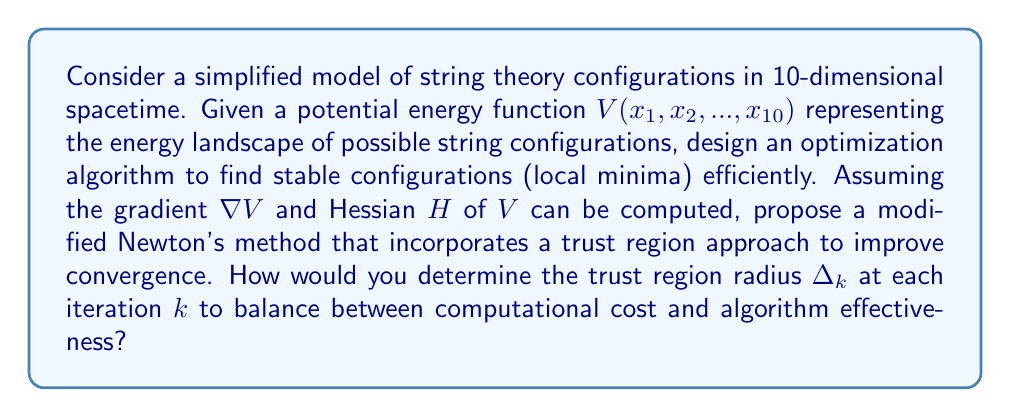Give your solution to this math problem. To solve this problem, we'll design a modified Newton's method with a trust region approach. This method is particularly suitable for finding local minima in high-dimensional spaces, such as the 10-dimensional configuration space in our simplified string theory model.

1. Standard Newton's method:
   The standard Newton's method for optimization is given by:
   $$x_{k+1} = x_k - H_k^{-1}\nabla V_k$$
   where $H_k$ is the Hessian and $\nabla V_k$ is the gradient at $x_k$.

2. Trust Region Modification:
   In the trust region approach, we solve the subproblem:
   $$\min_{p} m_k(p) = V_k + \nabla V_k^T p + \frac{1}{2}p^T H_k p$$
   subject to $\|p\| \leq \Delta_k$, where $\Delta_k$ is the trust region radius.

3. Determining $\Delta_k$:
   We can use the following approach to determine $\Delta_k$:
   
   a. Define the ratio:
      $$\rho_k = \frac{V_k - V(x_k + p_k)}{m_k(0) - m_k(p_k)}$$
   
   b. Update $\Delta_k$ based on $\rho_k$:
      $$\Delta_{k+1} = \begin{cases}
      \alpha_1 \Delta_k & \text{if } \rho_k < \eta_1 \\
      \Delta_k & \text{if } \eta_1 \leq \rho_k < \eta_2 \\
      \alpha_2 \Delta_k & \text{if } \rho_k \geq \eta_2
      \end{cases}$$
      where $0 < \eta_1 < \eta_2 < 1$ and $0 < \alpha_1 < 1 < \alpha_2$.

4. Algorithm steps:
   a. Initialize $x_0$, $\Delta_0$, and parameters $\eta_1$, $\eta_2$, $\alpha_1$, $\alpha_2$.
   b. For each iteration $k$:
      - Compute $\nabla V_k$ and $H_k$.
      - Solve the trust region subproblem to find $p_k$.
      - Compute $\rho_k$.
      - Update $x_{k+1}$ and $\Delta_{k+1}$ based on $\rho_k$.
      - Check for convergence.

5. Balancing computational cost and effectiveness:
   - Smaller $\Delta_k$ leads to more accurate steps but requires more iterations.
   - Larger $\Delta_k$ allows for bigger steps but may overshoot minima.
   - The adaptive nature of the trust region approach helps balance these factors.
   - In high dimensions (like our 10D space), a more conservative initial $\Delta_0$ might be preferable.

This approach combines the rapid convergence of Newton's method with the robustness of trust region methods, making it suitable for finding stable string theory configurations in higher dimensions.
Answer: The optimal trust region radius $\Delta_k$ at each iteration $k$ can be determined using the adaptive approach described in the explanation:

$$\Delta_{k+1} = \begin{cases}
\alpha_1 \Delta_k & \text{if } \rho_k < \eta_1 \\
\Delta_k & \text{if } \eta_1 \leq \rho_k < \eta_2 \\
\alpha_2 \Delta_k & \text{if } \rho_k \geq \eta_2
\end{cases}$$

where $\rho_k = \frac{V_k - V(x_k + p_k)}{m_k(0) - m_k(p_k)}$, and typical values for the parameters are $\eta_1 = 0.25$, $\eta_2 = 0.75$, $\alpha_1 = 0.5$, and $\alpha_2 = 2$. This adaptive approach balances computational cost and algorithm effectiveness by adjusting the trust region size based on the model's accuracy at each iteration. 